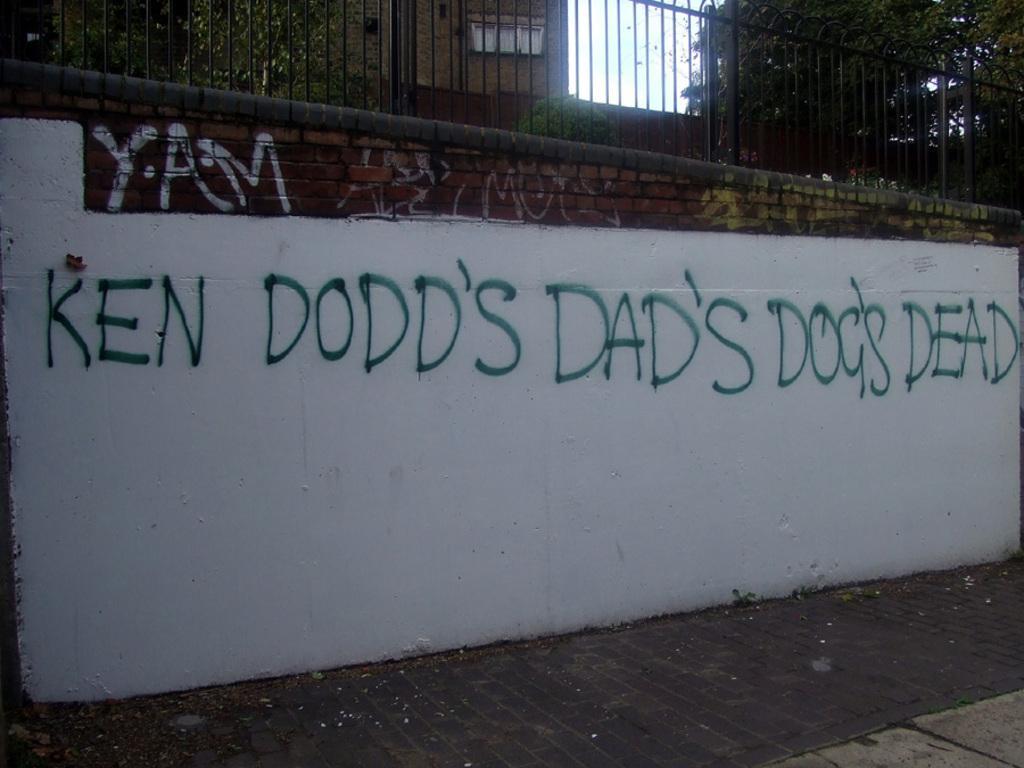Describe this image in one or two sentences. In this image there is some text written on the brick wall, above the wall there is a metal rod fence, behind the fence there are trees and buildings. 